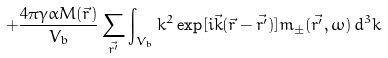<formula> <loc_0><loc_0><loc_500><loc_500>+ \frac { 4 \pi \gamma \alpha M ( \vec { r } ) } { V _ { b } } \sum _ { \vec { r ^ { \prime } } } \int _ { V _ { b } } k ^ { 2 } \exp [ i \vec { k } ( \vec { r } - \vec { r ^ { \prime } } ) ] m _ { \pm } ( \vec { r ^ { \prime } } , \omega ) \, d ^ { 3 } k</formula> 